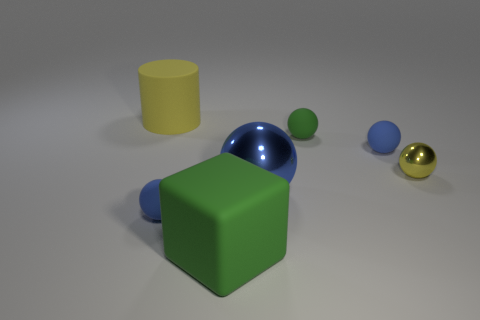Subtract all blue spheres. How many were subtracted if there are1blue spheres left? 2 Subtract all blue spheres. How many spheres are left? 2 Subtract 2 balls. How many balls are left? 3 Subtract all cylinders. How many objects are left? 6 Subtract all green spheres. How many spheres are left? 4 Subtract all large metallic things. Subtract all small rubber objects. How many objects are left? 3 Add 4 big spheres. How many big spheres are left? 5 Add 7 large purple matte blocks. How many large purple matte blocks exist? 7 Add 1 rubber cubes. How many objects exist? 8 Subtract 0 red cylinders. How many objects are left? 7 